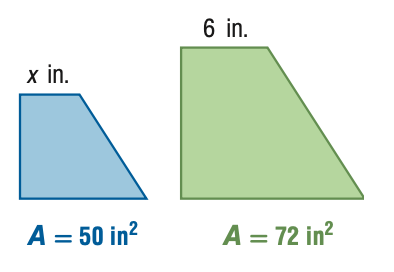Answer the mathemtical geometry problem and directly provide the correct option letter.
Question: For the pair of similar figures, use the given areas to find x.
Choices: A: 4.2 B: 5 C: 7.2 D: 8.6 B 